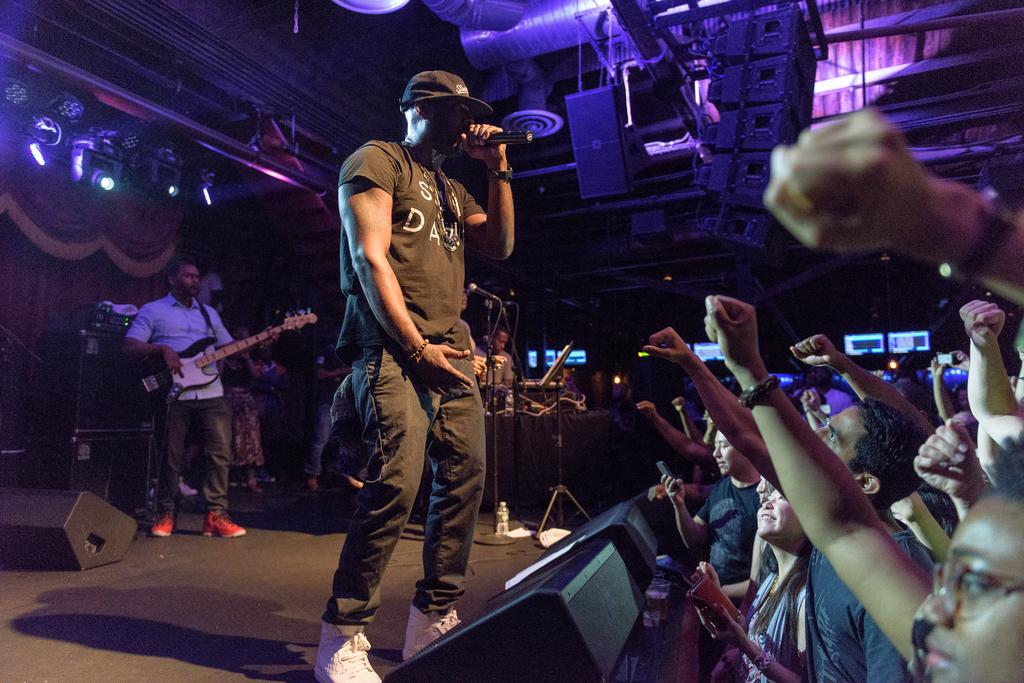How many people are in the image? There are people in the image. What is the man with the guitar doing? The man is standing and singing on a mic while holding a guitar. What type of volleyball game is being played in the image? There is no volleyball game present in the image. How many tickets are available for the show in the image? There is no show or mention of tickets in the image. 